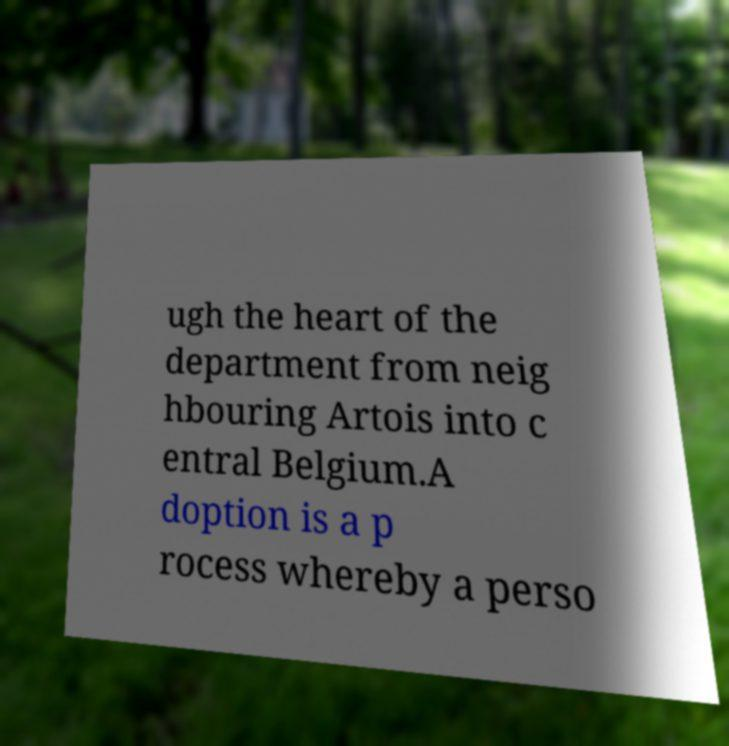For documentation purposes, I need the text within this image transcribed. Could you provide that? ugh the heart of the department from neig hbouring Artois into c entral Belgium.A doption is a p rocess whereby a perso 